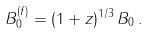Convert formula to latex. <formula><loc_0><loc_0><loc_500><loc_500>B ^ { ( f ) } _ { 0 } = ( 1 + z ) ^ { 1 / 3 } \, B _ { 0 } \, .</formula> 